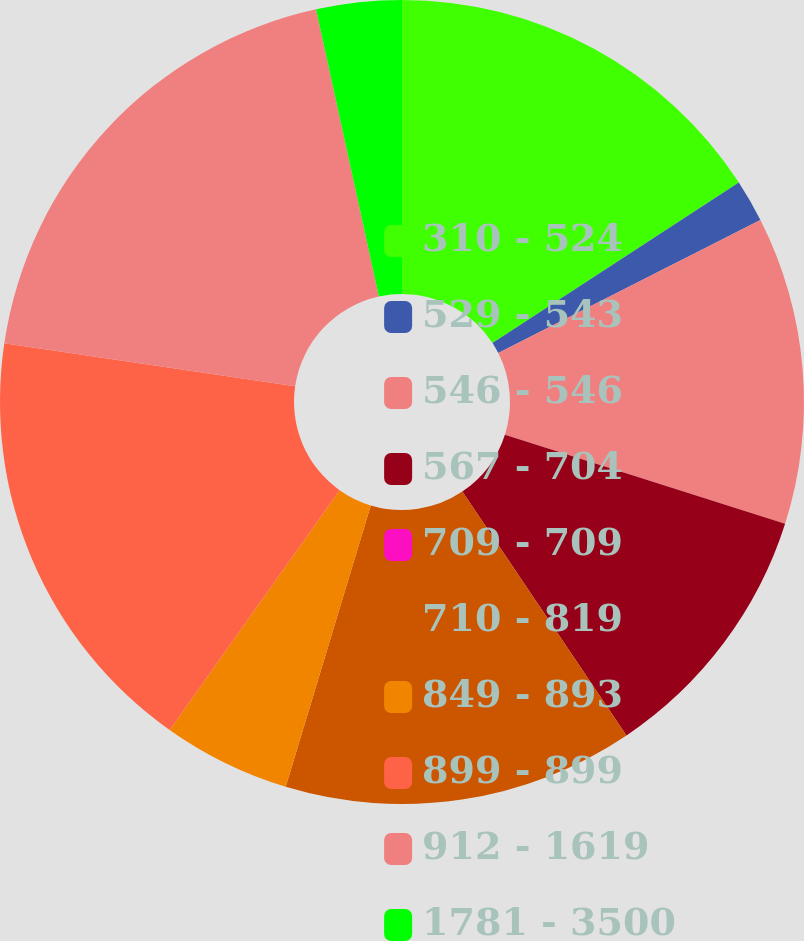Convert chart. <chart><loc_0><loc_0><loc_500><loc_500><pie_chart><fcel>310 - 524<fcel>529 - 543<fcel>546 - 546<fcel>567 - 704<fcel>709 - 709<fcel>710 - 819<fcel>849 - 893<fcel>899 - 899<fcel>912 - 1619<fcel>1781 - 3500<nl><fcel>15.81%<fcel>1.71%<fcel>12.38%<fcel>10.67%<fcel>0.0%<fcel>14.1%<fcel>5.14%<fcel>17.52%<fcel>19.24%<fcel>3.43%<nl></chart> 